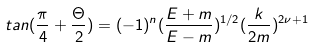Convert formula to latex. <formula><loc_0><loc_0><loc_500><loc_500>t a n ( \frac { \pi } { 4 } + \frac { \Theta } { 2 } ) = ( - 1 ) ^ { n } ( \frac { E + m } { E - m } ) ^ { 1 / 2 } ( \frac { k } { 2 m } ) ^ { 2 \nu + 1 }</formula> 